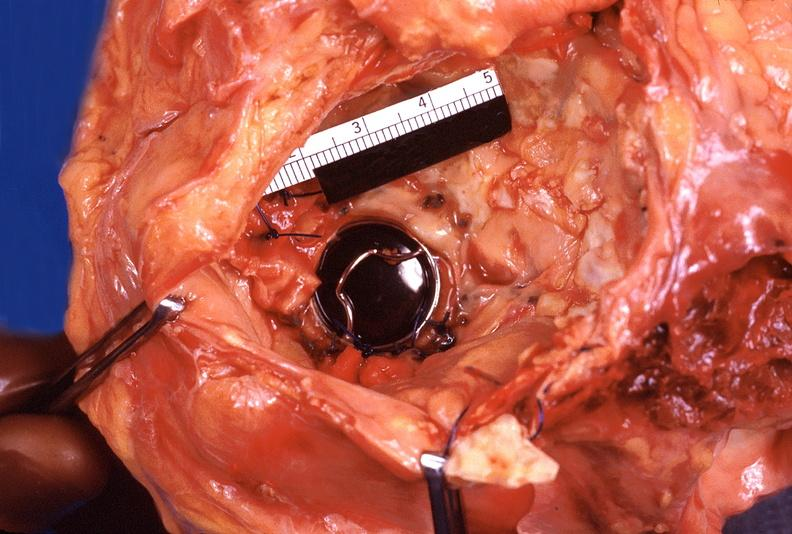what does this image show?
Answer the question using a single word or phrase. Heart 